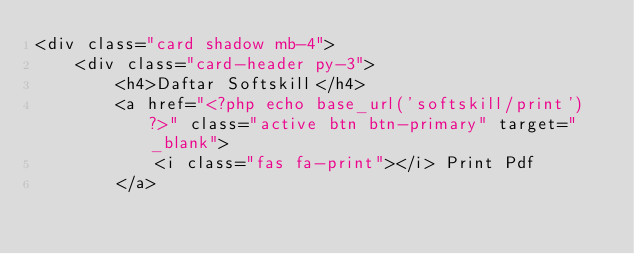<code> <loc_0><loc_0><loc_500><loc_500><_PHP_><div class="card shadow mb-4">
    <div class="card-header py-3">
        <h4>Daftar Softskill</h4>
        <a href="<?php echo base_url('softskill/print') ?>" class="active btn btn-primary" target="_blank">
            <i class="fas fa-print"></i> Print Pdf
        </a></code> 